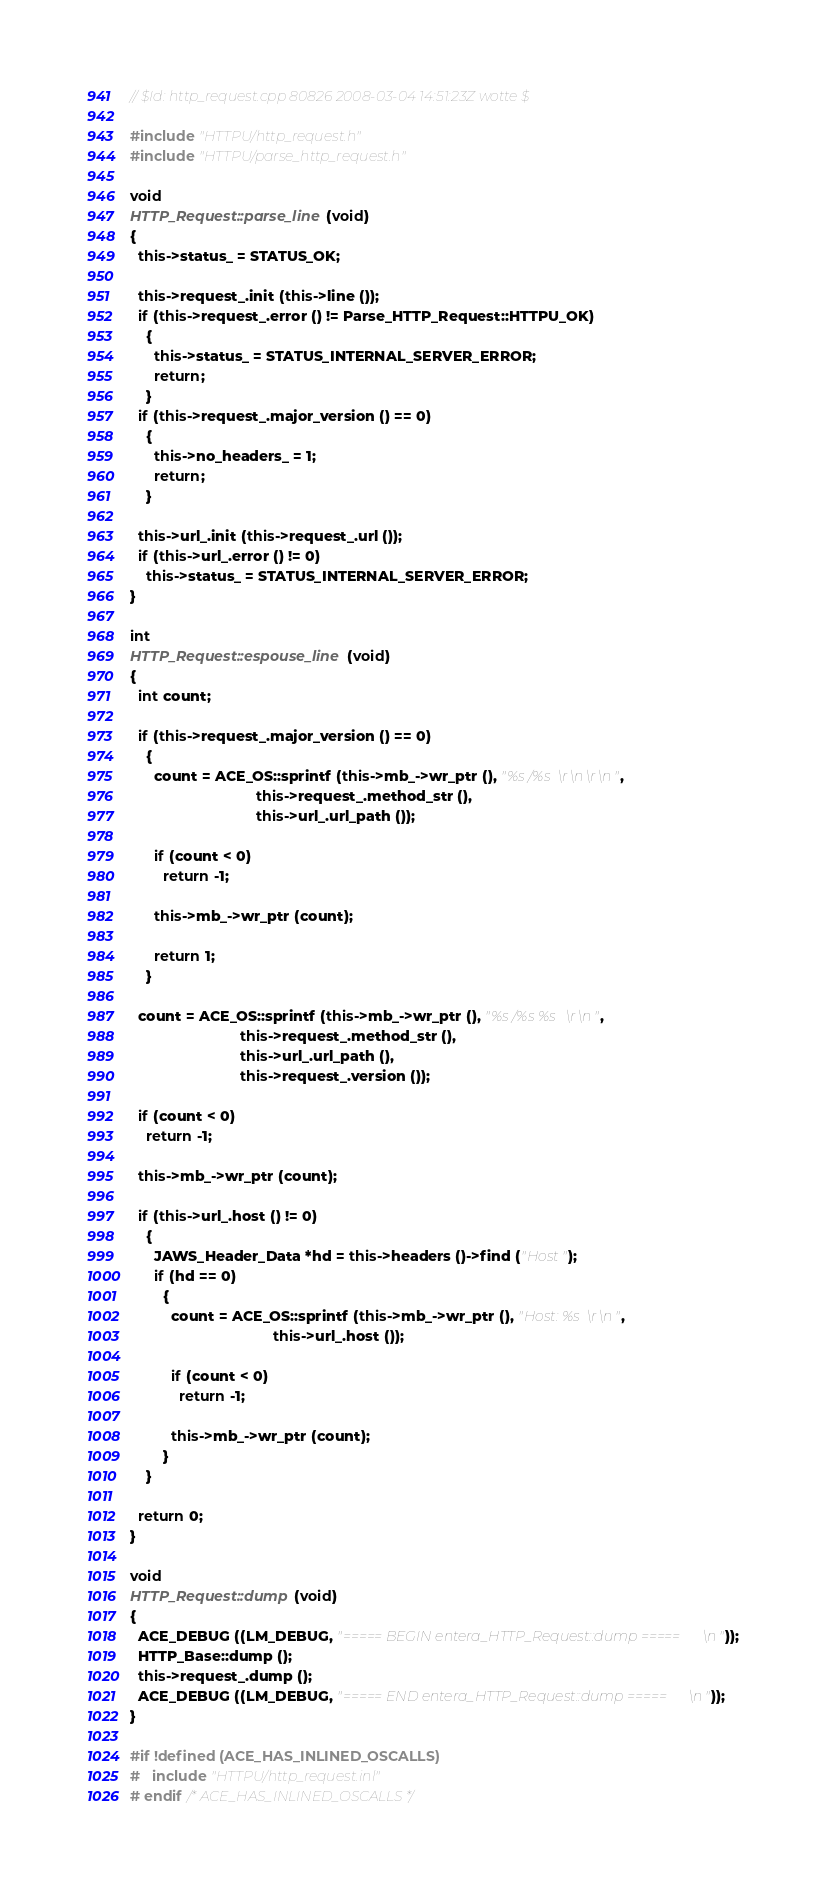Convert code to text. <code><loc_0><loc_0><loc_500><loc_500><_C++_>// $Id: http_request.cpp 80826 2008-03-04 14:51:23Z wotte $

#include "HTTPU/http_request.h"
#include "HTTPU/parse_http_request.h"

void
HTTP_Request::parse_line (void)
{
  this->status_ = STATUS_OK;

  this->request_.init (this->line ());
  if (this->request_.error () != Parse_HTTP_Request::HTTPU_OK)
    {
      this->status_ = STATUS_INTERNAL_SERVER_ERROR;
      return;
    }
  if (this->request_.major_version () == 0)
    {
      this->no_headers_ = 1;
      return;
    }

  this->url_.init (this->request_.url ());
  if (this->url_.error () != 0)
    this->status_ = STATUS_INTERNAL_SERVER_ERROR;
}

int
HTTP_Request::espouse_line (void)
{
  int count;

  if (this->request_.major_version () == 0)
    {
      count = ACE_OS::sprintf (this->mb_->wr_ptr (), "%s /%s\r\n\r\n",
                               this->request_.method_str (),
                               this->url_.url_path ());

      if (count < 0)
        return -1;

      this->mb_->wr_ptr (count);

      return 1;
    }

  count = ACE_OS::sprintf (this->mb_->wr_ptr (), "%s /%s %s\r\n",
                           this->request_.method_str (),
                           this->url_.url_path (),
                           this->request_.version ());

  if (count < 0)
    return -1;

  this->mb_->wr_ptr (count);

  if (this->url_.host () != 0)
    {
      JAWS_Header_Data *hd = this->headers ()->find ("Host");
      if (hd == 0)
        {
          count = ACE_OS::sprintf (this->mb_->wr_ptr (), "Host: %s\r\n",
                                   this->url_.host ());

          if (count < 0)
            return -1;

          this->mb_->wr_ptr (count);
        }
    }

  return 0;
}

void
HTTP_Request::dump (void)
{
  ACE_DEBUG ((LM_DEBUG, "===== BEGIN entera_HTTP_Request::dump =====\n"));
  HTTP_Base::dump ();
  this->request_.dump ();
  ACE_DEBUG ((LM_DEBUG, "===== END entera_HTTP_Request::dump =====\n"));
}

#if !defined (ACE_HAS_INLINED_OSCALLS)
#   include "HTTPU/http_request.inl"
# endif /* ACE_HAS_INLINED_OSCALLS */
</code> 